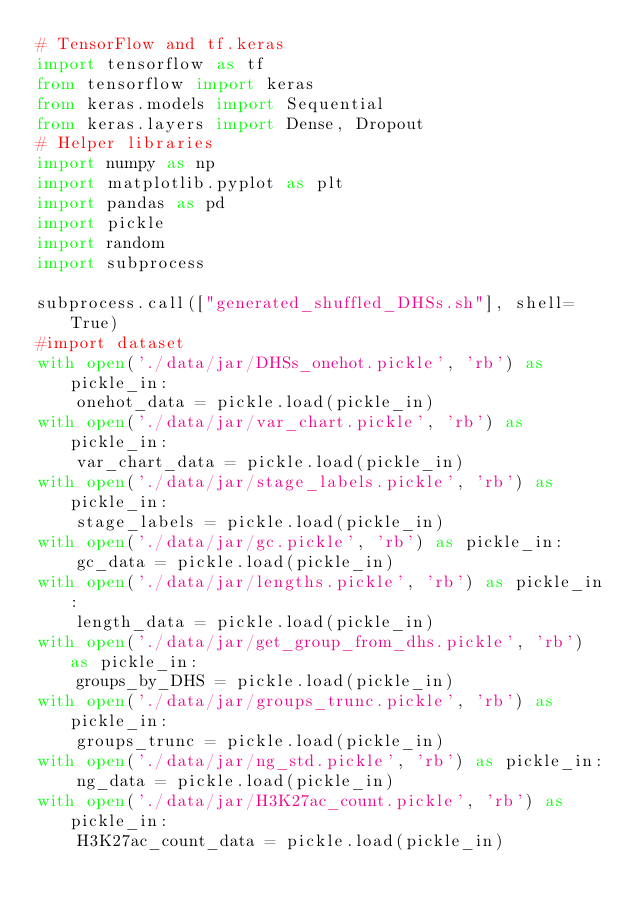<code> <loc_0><loc_0><loc_500><loc_500><_Python_># TensorFlow and tf.keras
import tensorflow as tf
from tensorflow import keras
from keras.models import Sequential
from keras.layers import Dense, Dropout
# Helper libraries
import numpy as np
import matplotlib.pyplot as plt
import pandas as pd
import pickle
import random
import subprocess

subprocess.call(["generated_shuffled_DHSs.sh"], shell=True)
#import dataset
with open('./data/jar/DHSs_onehot.pickle', 'rb') as pickle_in:
    onehot_data = pickle.load(pickle_in)
with open('./data/jar/var_chart.pickle', 'rb') as pickle_in:
    var_chart_data = pickle.load(pickle_in)
with open('./data/jar/stage_labels.pickle', 'rb') as pickle_in:
    stage_labels = pickle.load(pickle_in)
with open('./data/jar/gc.pickle', 'rb') as pickle_in:
    gc_data = pickle.load(pickle_in)
with open('./data/jar/lengths.pickle', 'rb') as pickle_in:
    length_data = pickle.load(pickle_in)
with open('./data/jar/get_group_from_dhs.pickle', 'rb') as pickle_in:
    groups_by_DHS = pickle.load(pickle_in)
with open('./data/jar/groups_trunc.pickle', 'rb') as pickle_in:
    groups_trunc = pickle.load(pickle_in)
with open('./data/jar/ng_std.pickle', 'rb') as pickle_in:
    ng_data = pickle.load(pickle_in)
with open('./data/jar/H3K27ac_count.pickle', 'rb') as pickle_in:
    H3K27ac_count_data = pickle.load(pickle_in)</code> 